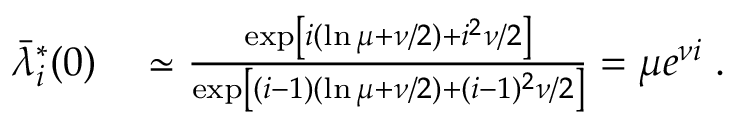<formula> <loc_0><loc_0><loc_500><loc_500>\begin{array} { r l } { \bar { \lambda } _ { i } ^ { * } ( 0 ) } & \simeq \frac { \exp \left [ i ( \ln \mu + \nu / 2 ) + i ^ { 2 } \nu / 2 \right ] } { \exp \left [ ( i - 1 ) ( \ln \mu + \nu / 2 ) + ( i - 1 ) ^ { 2 } \nu / 2 \right ] } = \mu e ^ { \nu i } \, . } \end{array}</formula> 